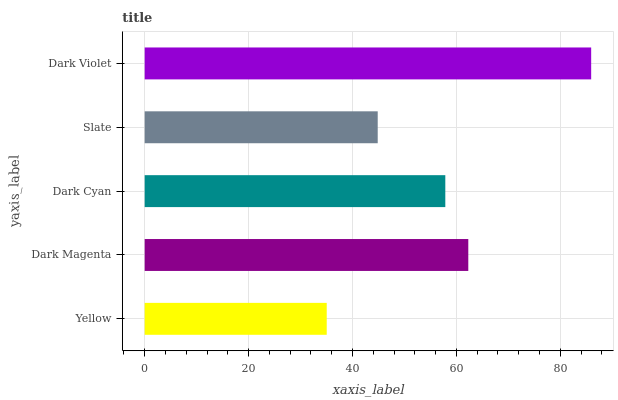Is Yellow the minimum?
Answer yes or no. Yes. Is Dark Violet the maximum?
Answer yes or no. Yes. Is Dark Magenta the minimum?
Answer yes or no. No. Is Dark Magenta the maximum?
Answer yes or no. No. Is Dark Magenta greater than Yellow?
Answer yes or no. Yes. Is Yellow less than Dark Magenta?
Answer yes or no. Yes. Is Yellow greater than Dark Magenta?
Answer yes or no. No. Is Dark Magenta less than Yellow?
Answer yes or no. No. Is Dark Cyan the high median?
Answer yes or no. Yes. Is Dark Cyan the low median?
Answer yes or no. Yes. Is Yellow the high median?
Answer yes or no. No. Is Yellow the low median?
Answer yes or no. No. 